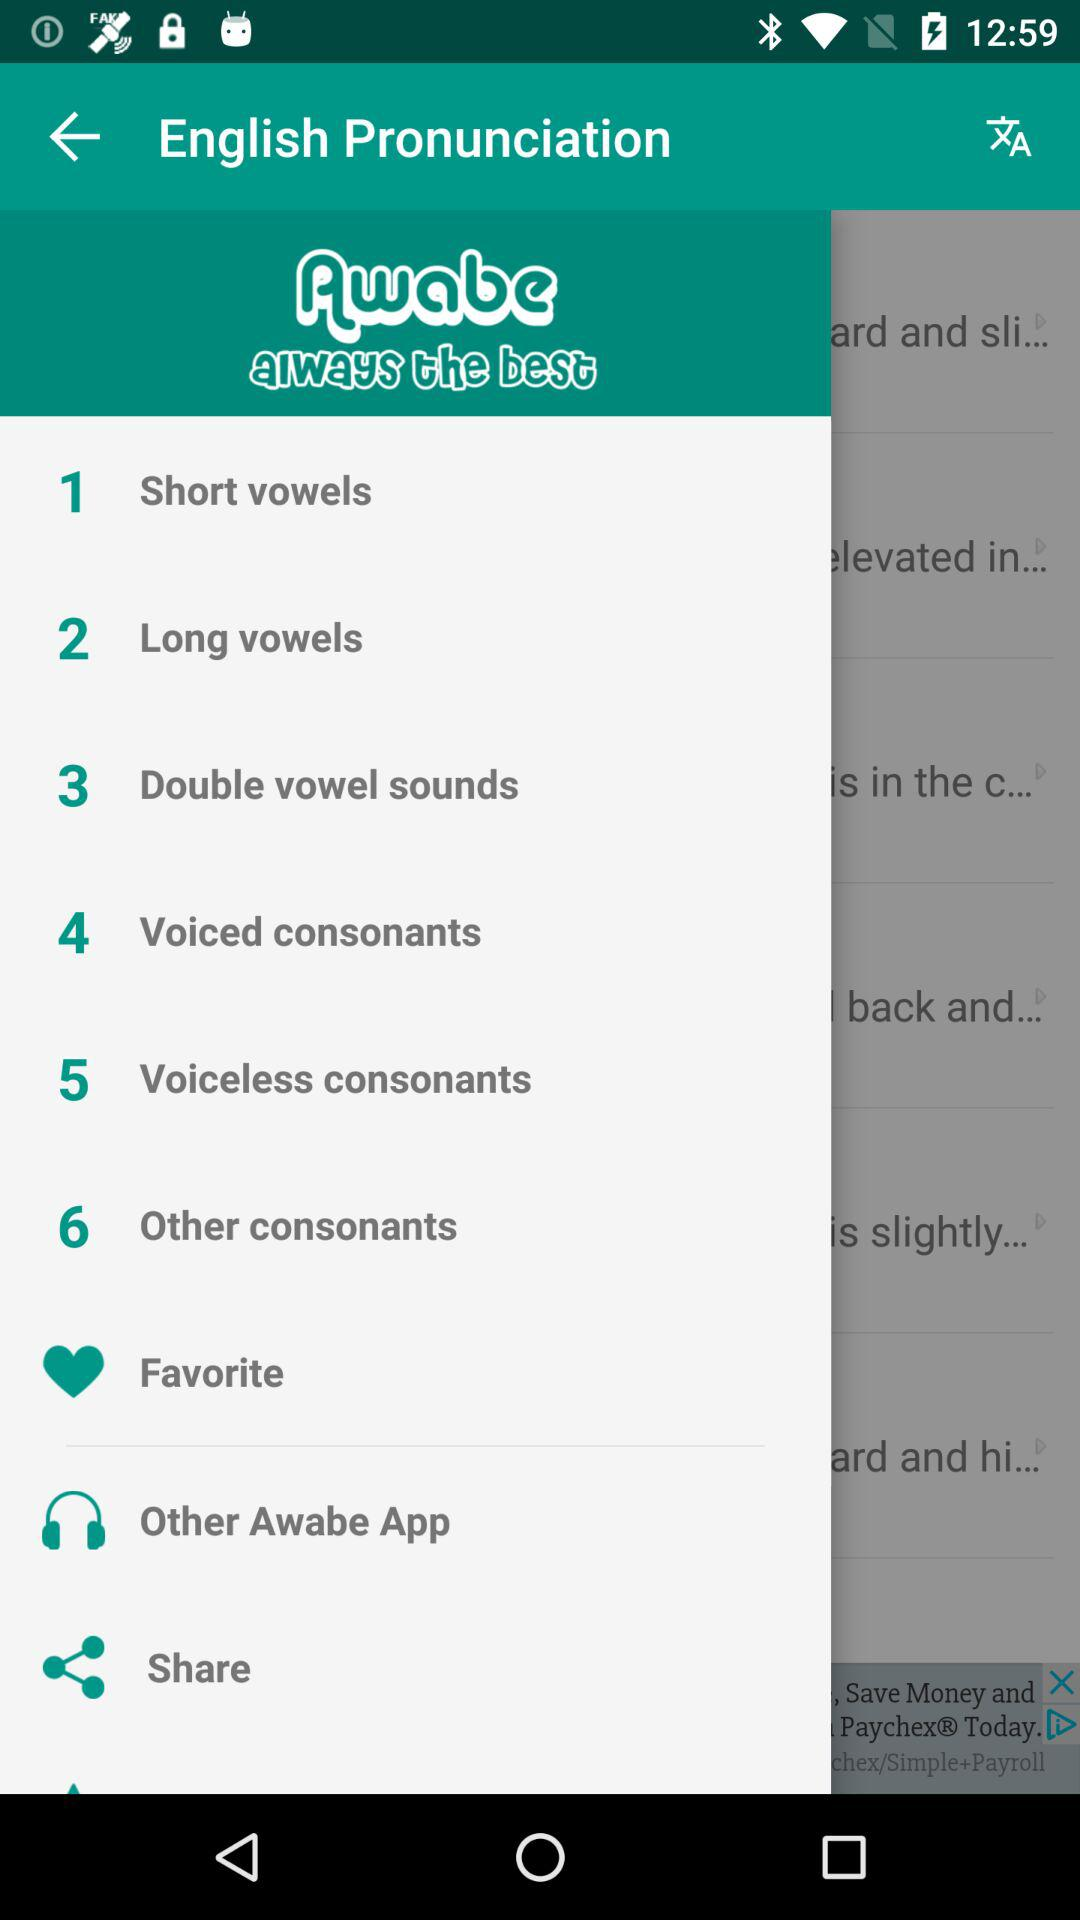What is the name of the application?
When the provided information is insufficient, respond with <no answer>. <no answer> 